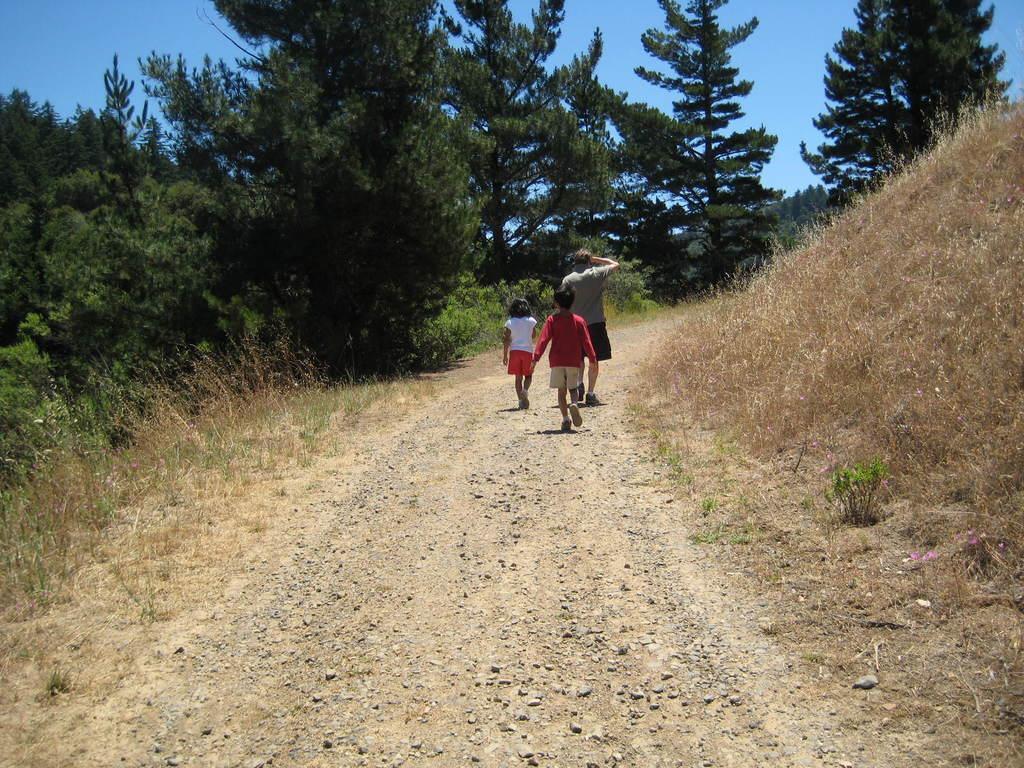Please provide a concise description of this image. This picture consists of road in the middle and I can see two chairs and one person walking on road and on the left side I can see trees and the sky and on the right side I can see grass 